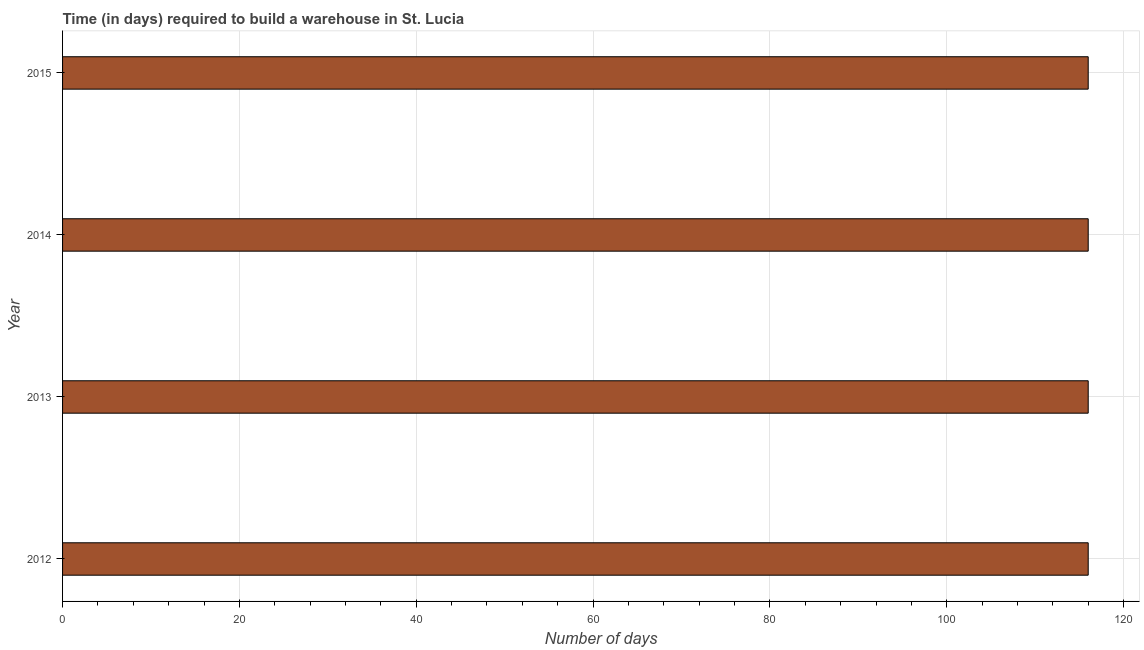What is the title of the graph?
Your answer should be very brief. Time (in days) required to build a warehouse in St. Lucia. What is the label or title of the X-axis?
Your response must be concise. Number of days. What is the label or title of the Y-axis?
Provide a short and direct response. Year. What is the time required to build a warehouse in 2013?
Your answer should be very brief. 116. Across all years, what is the maximum time required to build a warehouse?
Provide a succinct answer. 116. Across all years, what is the minimum time required to build a warehouse?
Provide a succinct answer. 116. What is the sum of the time required to build a warehouse?
Provide a succinct answer. 464. What is the average time required to build a warehouse per year?
Provide a short and direct response. 116. What is the median time required to build a warehouse?
Give a very brief answer. 116. What is the difference between the highest and the second highest time required to build a warehouse?
Your answer should be very brief. 0. How many bars are there?
Make the answer very short. 4. Are all the bars in the graph horizontal?
Give a very brief answer. Yes. What is the difference between two consecutive major ticks on the X-axis?
Offer a terse response. 20. What is the Number of days of 2012?
Offer a terse response. 116. What is the Number of days in 2013?
Your answer should be very brief. 116. What is the Number of days in 2014?
Keep it short and to the point. 116. What is the Number of days in 2015?
Provide a short and direct response. 116. What is the difference between the Number of days in 2012 and 2013?
Provide a short and direct response. 0. What is the difference between the Number of days in 2013 and 2014?
Provide a succinct answer. 0. What is the difference between the Number of days in 2013 and 2015?
Your response must be concise. 0. What is the difference between the Number of days in 2014 and 2015?
Offer a terse response. 0. What is the ratio of the Number of days in 2012 to that in 2013?
Keep it short and to the point. 1. 